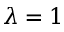Convert formula to latex. <formula><loc_0><loc_0><loc_500><loc_500>\lambda = 1</formula> 